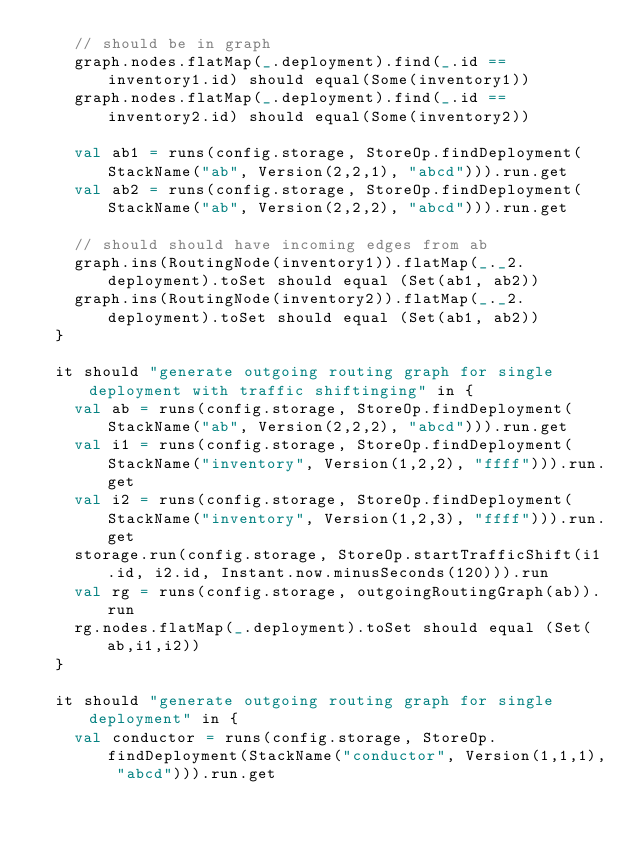<code> <loc_0><loc_0><loc_500><loc_500><_Scala_>    // should be in graph
    graph.nodes.flatMap(_.deployment).find(_.id == inventory1.id) should equal(Some(inventory1))
    graph.nodes.flatMap(_.deployment).find(_.id == inventory2.id) should equal(Some(inventory2))

    val ab1 = runs(config.storage, StoreOp.findDeployment(StackName("ab", Version(2,2,1), "abcd"))).run.get
    val ab2 = runs(config.storage, StoreOp.findDeployment(StackName("ab", Version(2,2,2), "abcd"))).run.get

    // should should have incoming edges from ab
    graph.ins(RoutingNode(inventory1)).flatMap(_._2.deployment).toSet should equal (Set(ab1, ab2))
    graph.ins(RoutingNode(inventory2)).flatMap(_._2.deployment).toSet should equal (Set(ab1, ab2))
  }

  it should "generate outgoing routing graph for single deployment with traffic shiftinging" in {
    val ab = runs(config.storage, StoreOp.findDeployment(StackName("ab", Version(2,2,2), "abcd"))).run.get
    val i1 = runs(config.storage, StoreOp.findDeployment(StackName("inventory", Version(1,2,2), "ffff"))).run.get
    val i2 = runs(config.storage, StoreOp.findDeployment(StackName("inventory", Version(1,2,3), "ffff"))).run.get
    storage.run(config.storage, StoreOp.startTrafficShift(i1.id, i2.id, Instant.now.minusSeconds(120))).run
    val rg = runs(config.storage, outgoingRoutingGraph(ab)).run
    rg.nodes.flatMap(_.deployment).toSet should equal (Set(ab,i1,i2))
  }

  it should "generate outgoing routing graph for single deployment" in {
    val conductor = runs(config.storage, StoreOp.findDeployment(StackName("conductor", Version(1,1,1), "abcd"))).run.get</code> 